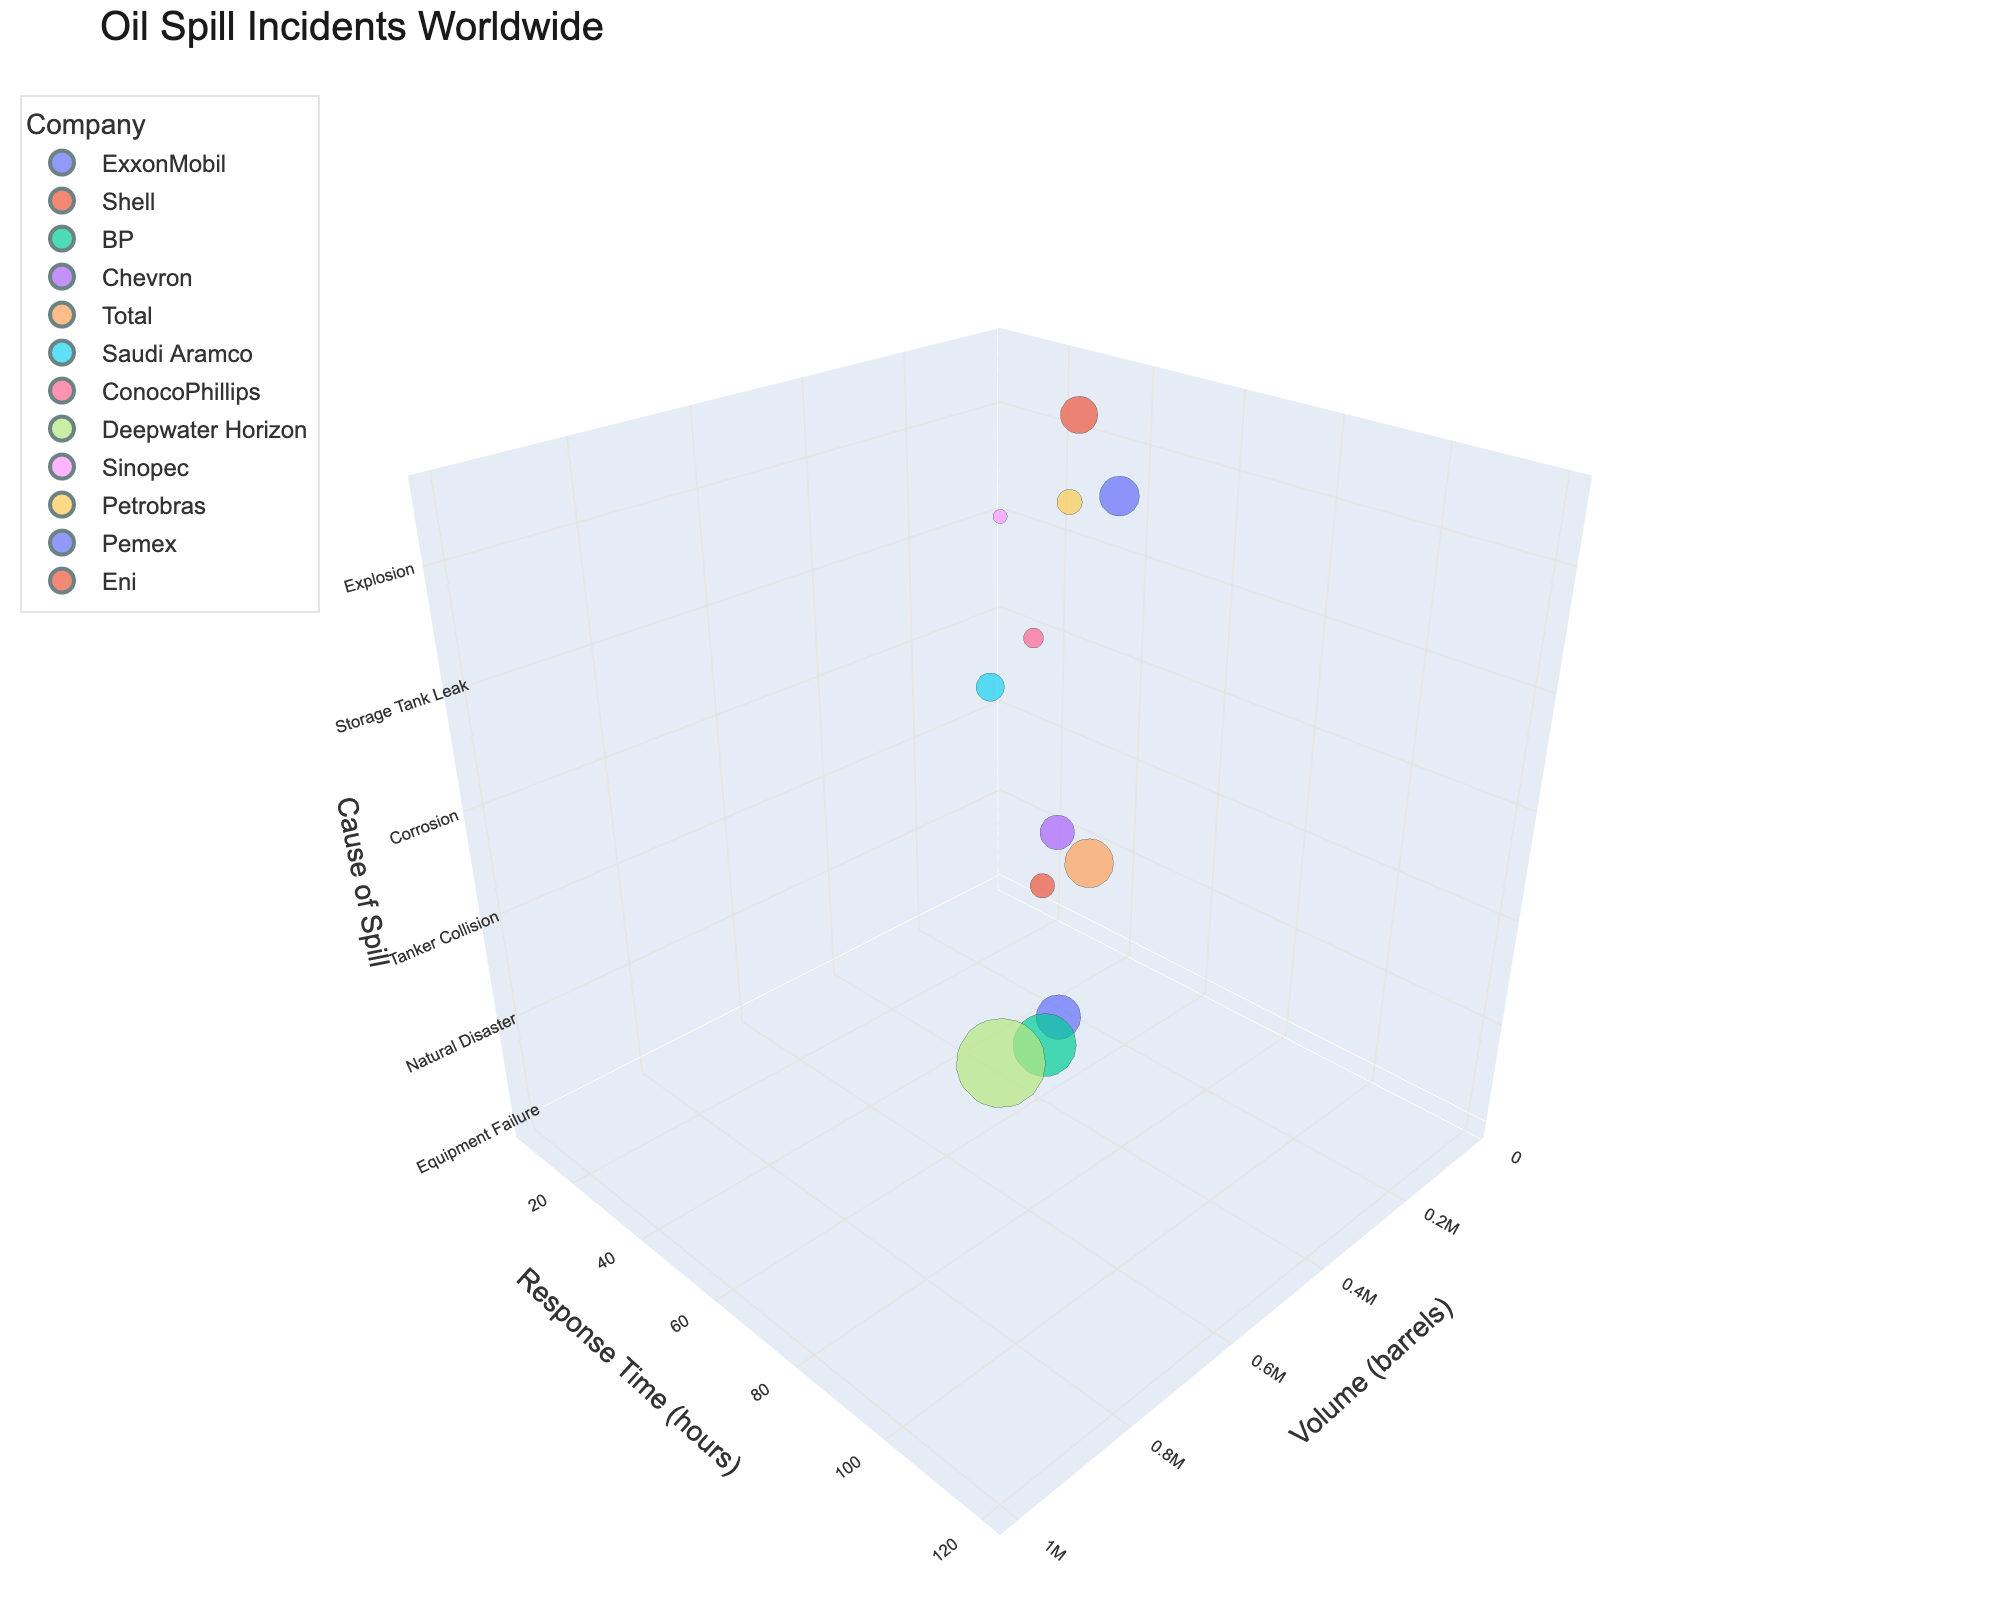How many oil spill incidents are displayed on the chart? Count the number of bubbles/data points in the chart. Each bubble represents one incident.
Answer: 12 What is the cause of the oil spill with the highest volume? Identify the bubble with the largest size, then check its z-axis value representing the cause of the spill.
Answer: Well Blowout Which company responded the fastest to an oil spill? Find the bubble positioned lowest on the y-axis (Response Time). The hover information for this bubble will show the company.
Answer: Sinopec Among the causes of spills, which one has the lowest volume incident? Identify the smallest bubble, then check the z-axis value representing the cause.
Answer: Storage Tank Leak What is the response time for Chevron's oil spill incident? Locate the bubble colored for Chevron and read off its y-axis value.
Answer: 36 hours Which incident took place in the Mediterranean Sea, and what was its volume? Hover over the bubbles to find the one labeled "Mediterranean Sea", then read its volume from the size or hover information.
Answer: Tanker Collision, 300,000 barrels How do the response times compare between oil spills caused by Equipment Failure and Explosion? Locate the bubbles for both causes and compare their y-axis positions (Response Time). Equipment Failure is at 48 hours, and Explosion is at 54 hours.
Answer: Explosion is longer by 6 hours Which cause of oil spill is associated with the highest number of barrels compared to Natural Disaster? Compare the bubble sizes between "Natural Disaster" and "Well Blowout" by looking at the z-axis and the size. Natural Disaster is at 500,000 barrels, and Well Blowout is at 1,000,000 barrels.
Answer: Well Blowout What is the average response time for incidents with volumes above 250,000 barrels? Identify bubbles with volumes above 250,000 barrels (Equipment Failure, Natural Disaster, Tanker Collision, Well Blowout). Their response times are 48, 72, 60, and 120 hours respectively. Calculate the average: (48+72+60+120)/4= 75 hours.
Answer: 75 hours Which incident has a response time less than 24 hours and occurred in the Red Sea? Find the bubble with a y-axis value under 24 hours and check its hover information for the location "Red Sea".
Answer: Sabotage 